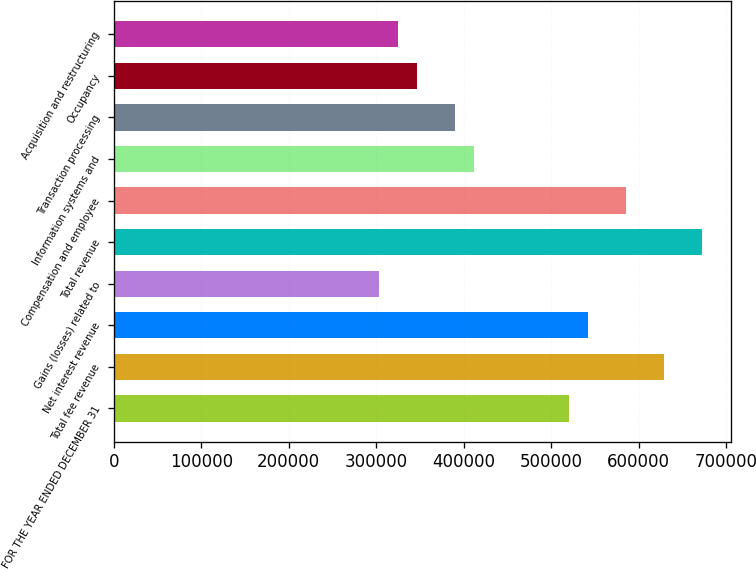Convert chart to OTSL. <chart><loc_0><loc_0><loc_500><loc_500><bar_chart><fcel>FOR THE YEAR ENDED DECEMBER 31<fcel>Total fee revenue<fcel>Net interest revenue<fcel>Gains (losses) related to<fcel>Total revenue<fcel>Compensation and employee<fcel>Information systems and<fcel>Transaction processing<fcel>Occupancy<fcel>Acquisition and restructuring<nl><fcel>520384<fcel>628797<fcel>542066<fcel>303558<fcel>672162<fcel>585432<fcel>411971<fcel>390288<fcel>346923<fcel>325240<nl></chart> 